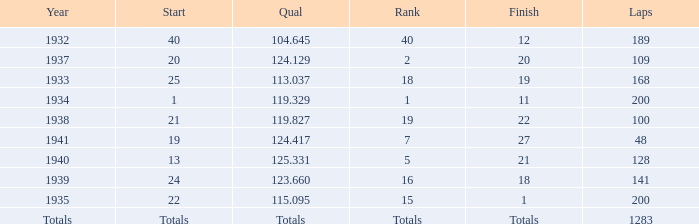What was the rank with the qual of 115.095? 15.0. 